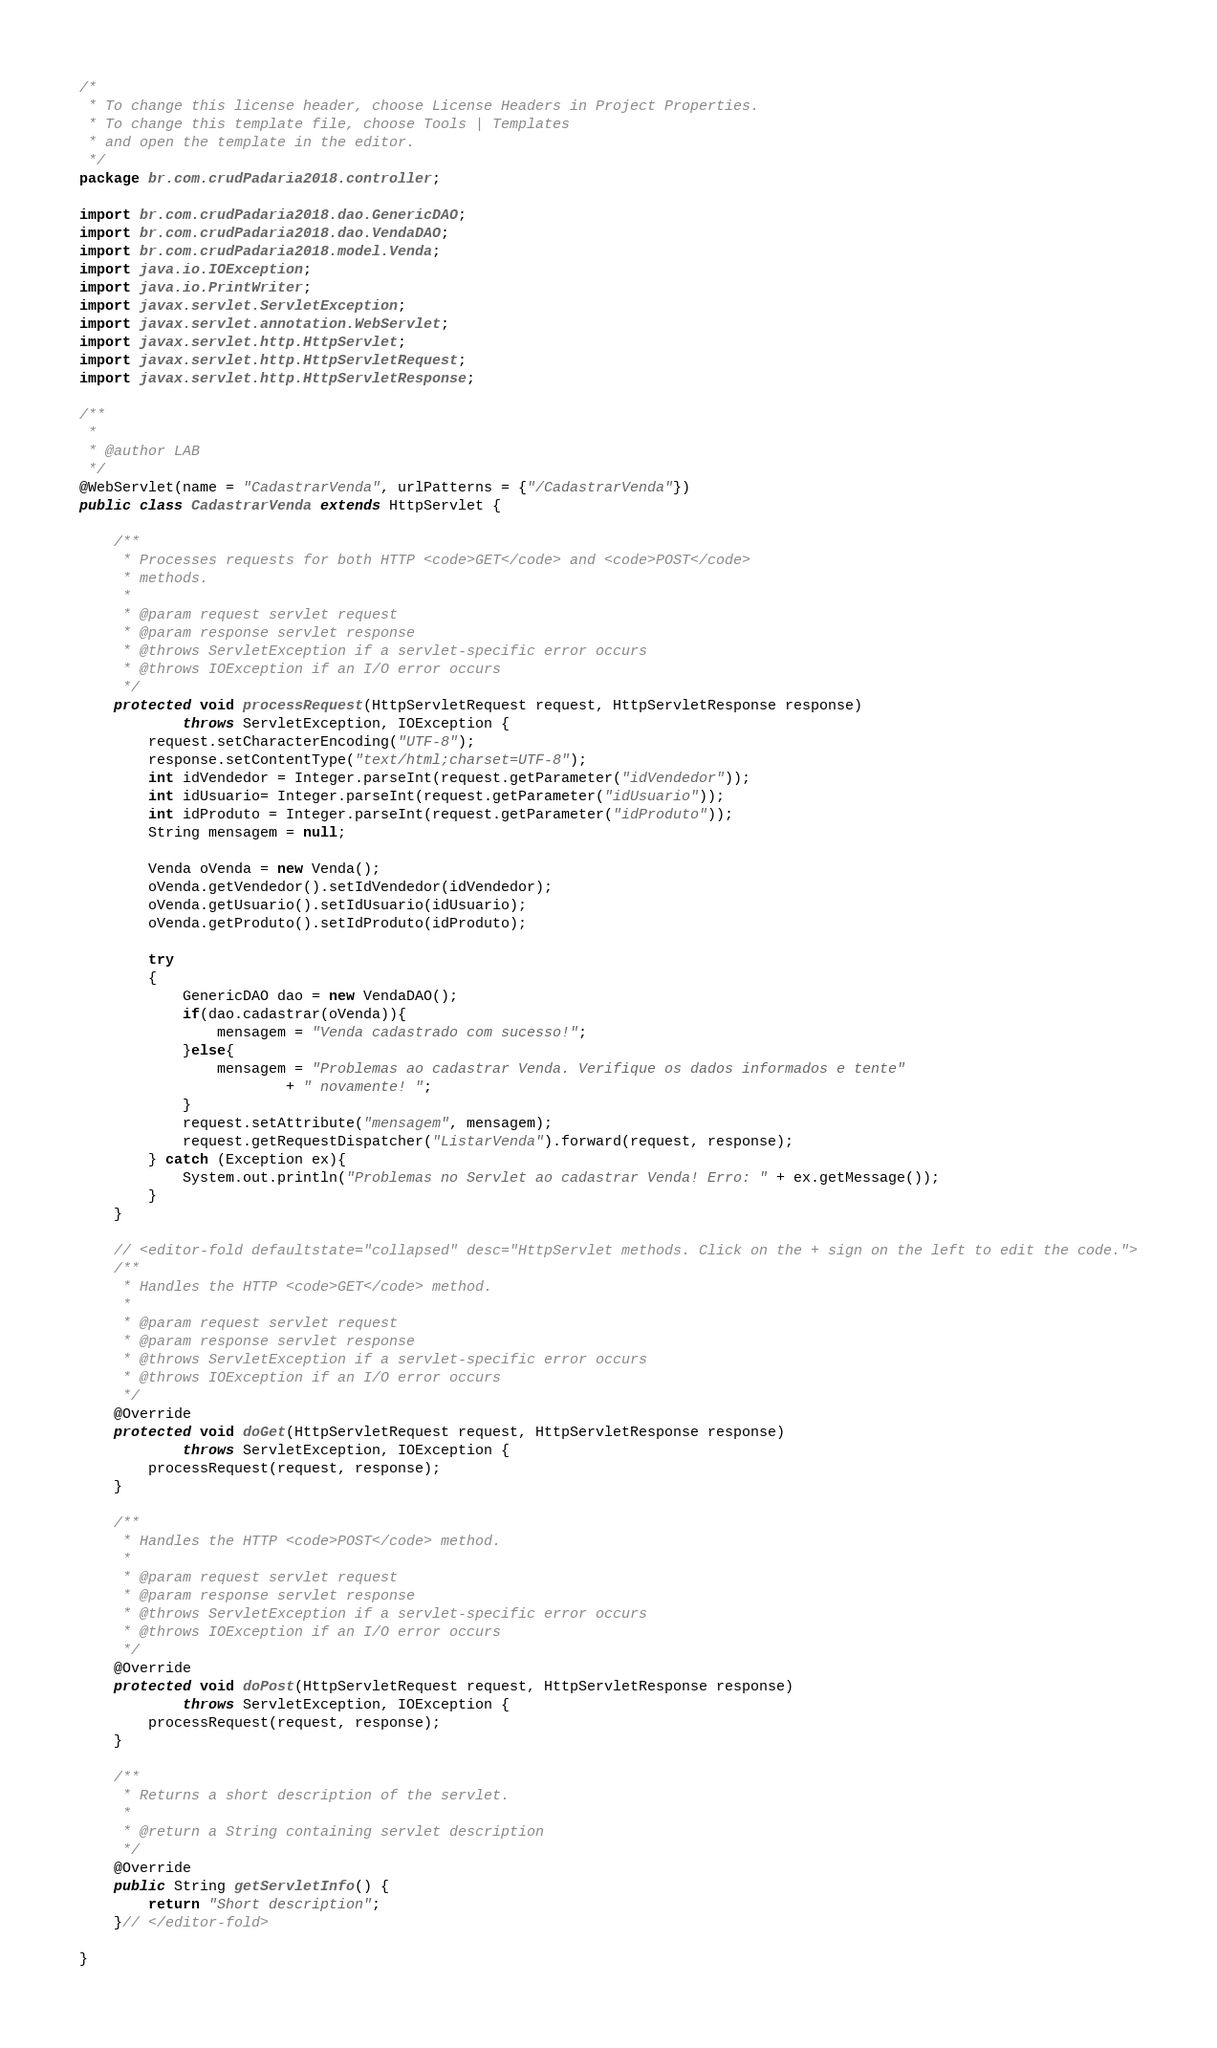Convert code to text. <code><loc_0><loc_0><loc_500><loc_500><_Java_>/*
 * To change this license header, choose License Headers in Project Properties.
 * To change this template file, choose Tools | Templates
 * and open the template in the editor.
 */
package br.com.crudPadaria2018.controller;

import br.com.crudPadaria2018.dao.GenericDAO;
import br.com.crudPadaria2018.dao.VendaDAO;
import br.com.crudPadaria2018.model.Venda;
import java.io.IOException;
import java.io.PrintWriter;
import javax.servlet.ServletException;
import javax.servlet.annotation.WebServlet;
import javax.servlet.http.HttpServlet;
import javax.servlet.http.HttpServletRequest;
import javax.servlet.http.HttpServletResponse;

/**
 *
 * @author LAB
 */
@WebServlet(name = "CadastrarVenda", urlPatterns = {"/CadastrarVenda"})
public class CadastrarVenda extends HttpServlet {

    /**
     * Processes requests for both HTTP <code>GET</code> and <code>POST</code>
     * methods.
     *
     * @param request servlet request
     * @param response servlet response
     * @throws ServletException if a servlet-specific error occurs
     * @throws IOException if an I/O error occurs
     */
    protected void processRequest(HttpServletRequest request, HttpServletResponse response)
            throws ServletException, IOException {
        request.setCharacterEncoding("UTF-8");
        response.setContentType("text/html;charset=UTF-8");
        int idVendedor = Integer.parseInt(request.getParameter("idVendedor"));
        int idUsuario= Integer.parseInt(request.getParameter("idUsuario"));
        int idProduto = Integer.parseInt(request.getParameter("idProduto"));
        String mensagem = null;
        
        Venda oVenda = new Venda();
        oVenda.getVendedor().setIdVendedor(idVendedor);
        oVenda.getUsuario().setIdUsuario(idUsuario);
        oVenda.getProduto().setIdProduto(idProduto);
        
        try
        {
            GenericDAO dao = new VendaDAO();
            if(dao.cadastrar(oVenda)){
                mensagem = "Venda cadastrado com sucesso!";
            }else{
                mensagem = "Problemas ao cadastrar Venda. Verifique os dados informados e tente"
                        + " novamente! ";
            }
            request.setAttribute("mensagem", mensagem);
            request.getRequestDispatcher("ListarVenda").forward(request, response);
        } catch (Exception ex){
            System.out.println("Problemas no Servlet ao cadastrar Venda! Erro: " + ex.getMessage());
        }
    }

    // <editor-fold defaultstate="collapsed" desc="HttpServlet methods. Click on the + sign on the left to edit the code.">
    /**
     * Handles the HTTP <code>GET</code> method.
     *
     * @param request servlet request
     * @param response servlet response
     * @throws ServletException if a servlet-specific error occurs
     * @throws IOException if an I/O error occurs
     */
    @Override
    protected void doGet(HttpServletRequest request, HttpServletResponse response)
            throws ServletException, IOException {
        processRequest(request, response);
    }

    /**
     * Handles the HTTP <code>POST</code> method.
     *
     * @param request servlet request
     * @param response servlet response
     * @throws ServletException if a servlet-specific error occurs
     * @throws IOException if an I/O error occurs
     */
    @Override
    protected void doPost(HttpServletRequest request, HttpServletResponse response)
            throws ServletException, IOException {
        processRequest(request, response);
    }

    /**
     * Returns a short description of the servlet.
     *
     * @return a String containing servlet description
     */
    @Override
    public String getServletInfo() {
        return "Short description";
    }// </editor-fold>

}
</code> 